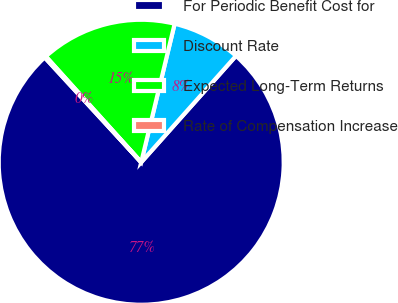Convert chart to OTSL. <chart><loc_0><loc_0><loc_500><loc_500><pie_chart><fcel>For Periodic Benefit Cost for<fcel>Discount Rate<fcel>Expected Long-Term Returns<fcel>Rate of Compensation Increase<nl><fcel>76.58%<fcel>7.81%<fcel>15.45%<fcel>0.17%<nl></chart> 